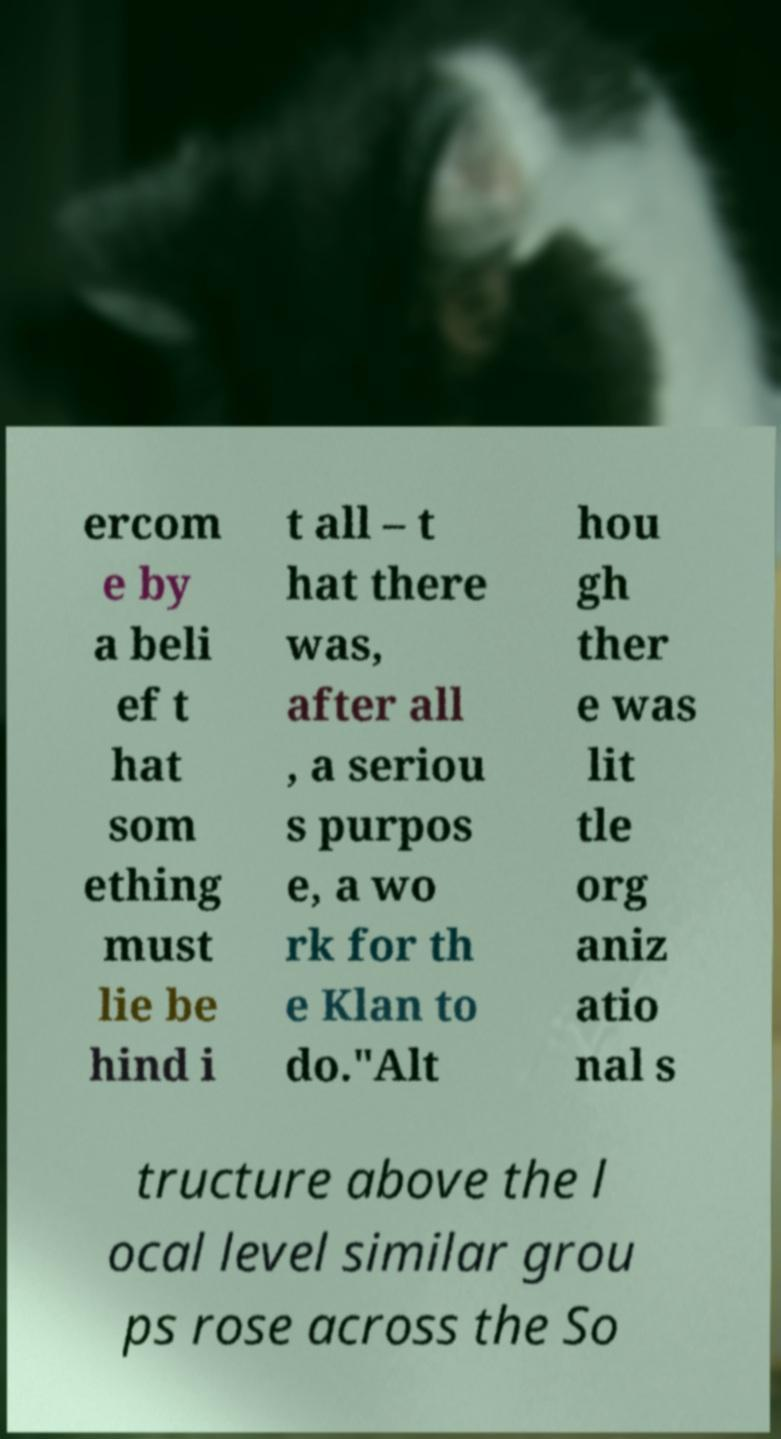I need the written content from this picture converted into text. Can you do that? ercom e by a beli ef t hat som ething must lie be hind i t all – t hat there was, after all , a seriou s purpos e, a wo rk for th e Klan to do."Alt hou gh ther e was lit tle org aniz atio nal s tructure above the l ocal level similar grou ps rose across the So 